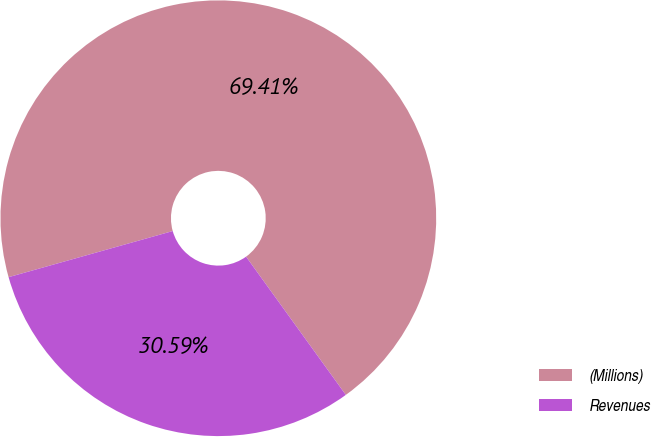Convert chart to OTSL. <chart><loc_0><loc_0><loc_500><loc_500><pie_chart><fcel>(Millions)<fcel>Revenues<nl><fcel>69.41%<fcel>30.59%<nl></chart> 